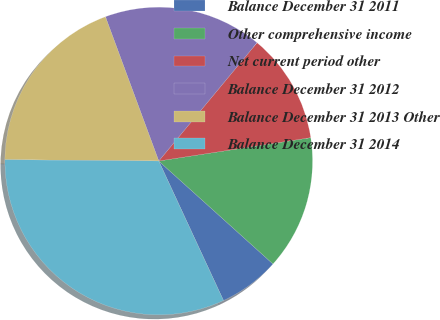<chart> <loc_0><loc_0><loc_500><loc_500><pie_chart><fcel>Balance December 31 2011<fcel>Other comprehensive income<fcel>Net current period other<fcel>Balance December 31 2012<fcel>Balance December 31 2013 Other<fcel>Balance December 31 2014<nl><fcel>6.41%<fcel>14.1%<fcel>11.54%<fcel>16.67%<fcel>19.23%<fcel>32.05%<nl></chart> 